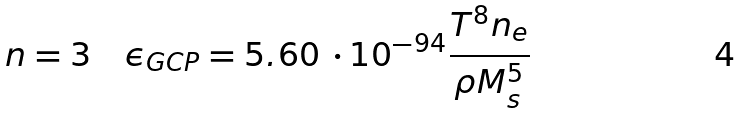<formula> <loc_0><loc_0><loc_500><loc_500>n = 3 \quad \epsilon _ { G C P } = 5 . 6 0 \, \cdot 1 0 ^ { - 9 4 } \frac { T ^ { 8 } n _ { e } } { \rho M _ { s } ^ { 5 } }</formula> 